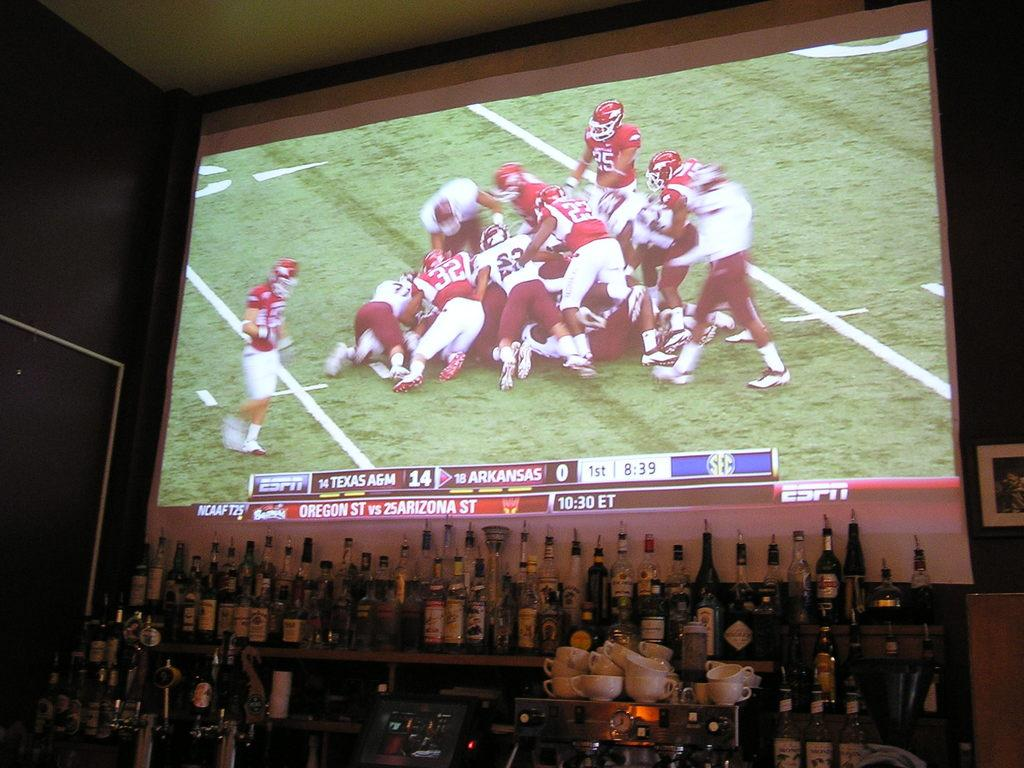<image>
Offer a succinct explanation of the picture presented. A huge screen playing a football gameon ESPN behind the bar 